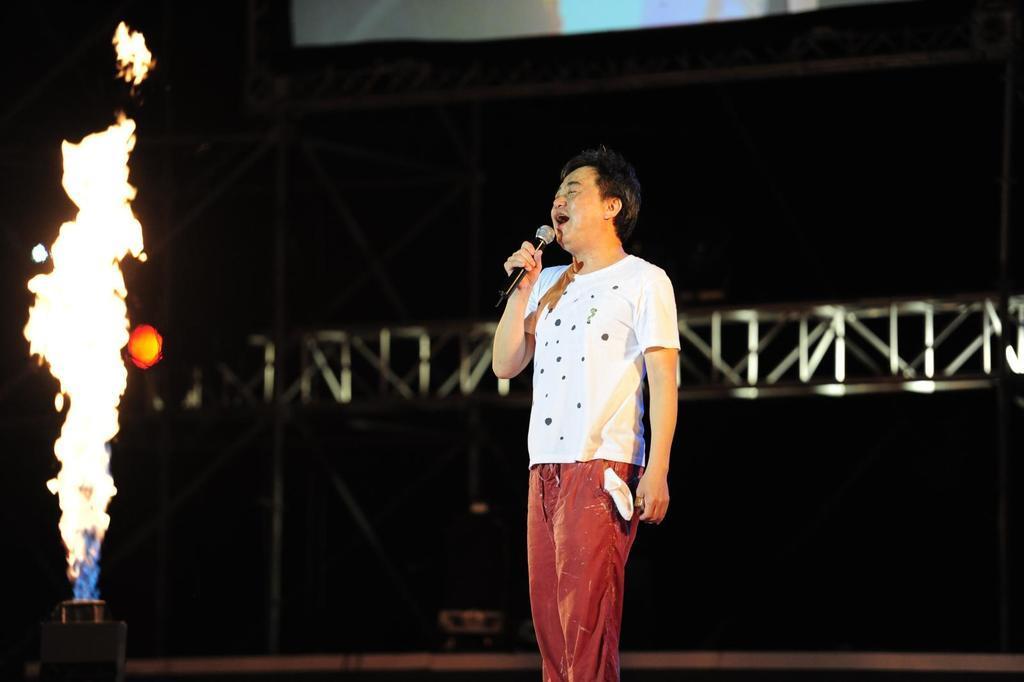Describe this image in one or two sentences. In this image we can see a man standing on the stage. A man is singing into a microphone. There is a fire at the left side of the image. 